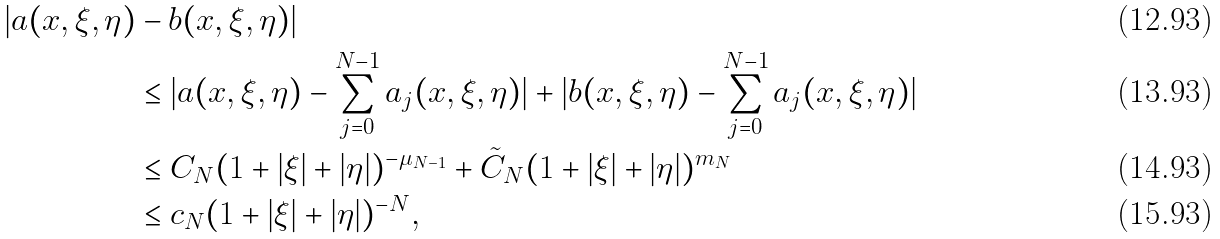Convert formula to latex. <formula><loc_0><loc_0><loc_500><loc_500>| a ( x , \xi , \eta ) & - b ( x , \xi , \eta ) | \\ & \leq | a ( x , \xi , \eta ) - \sum _ { j = 0 } ^ { N - 1 } a _ { j } ( x , \xi , \eta ) | + | b ( x , \xi , \eta ) - \sum _ { j = 0 } ^ { N - 1 } a _ { j } ( x , \xi , \eta ) | \\ & \leq C _ { N } ( 1 + | \xi | + | \eta | ) ^ { - \mu _ { N - 1 } } + \tilde { C } _ { N } ( 1 + | \xi | + | \eta | ) ^ { m _ { N } } \\ & \leq c _ { N } ( 1 + | \xi | + | \eta | ) ^ { - N } ,</formula> 